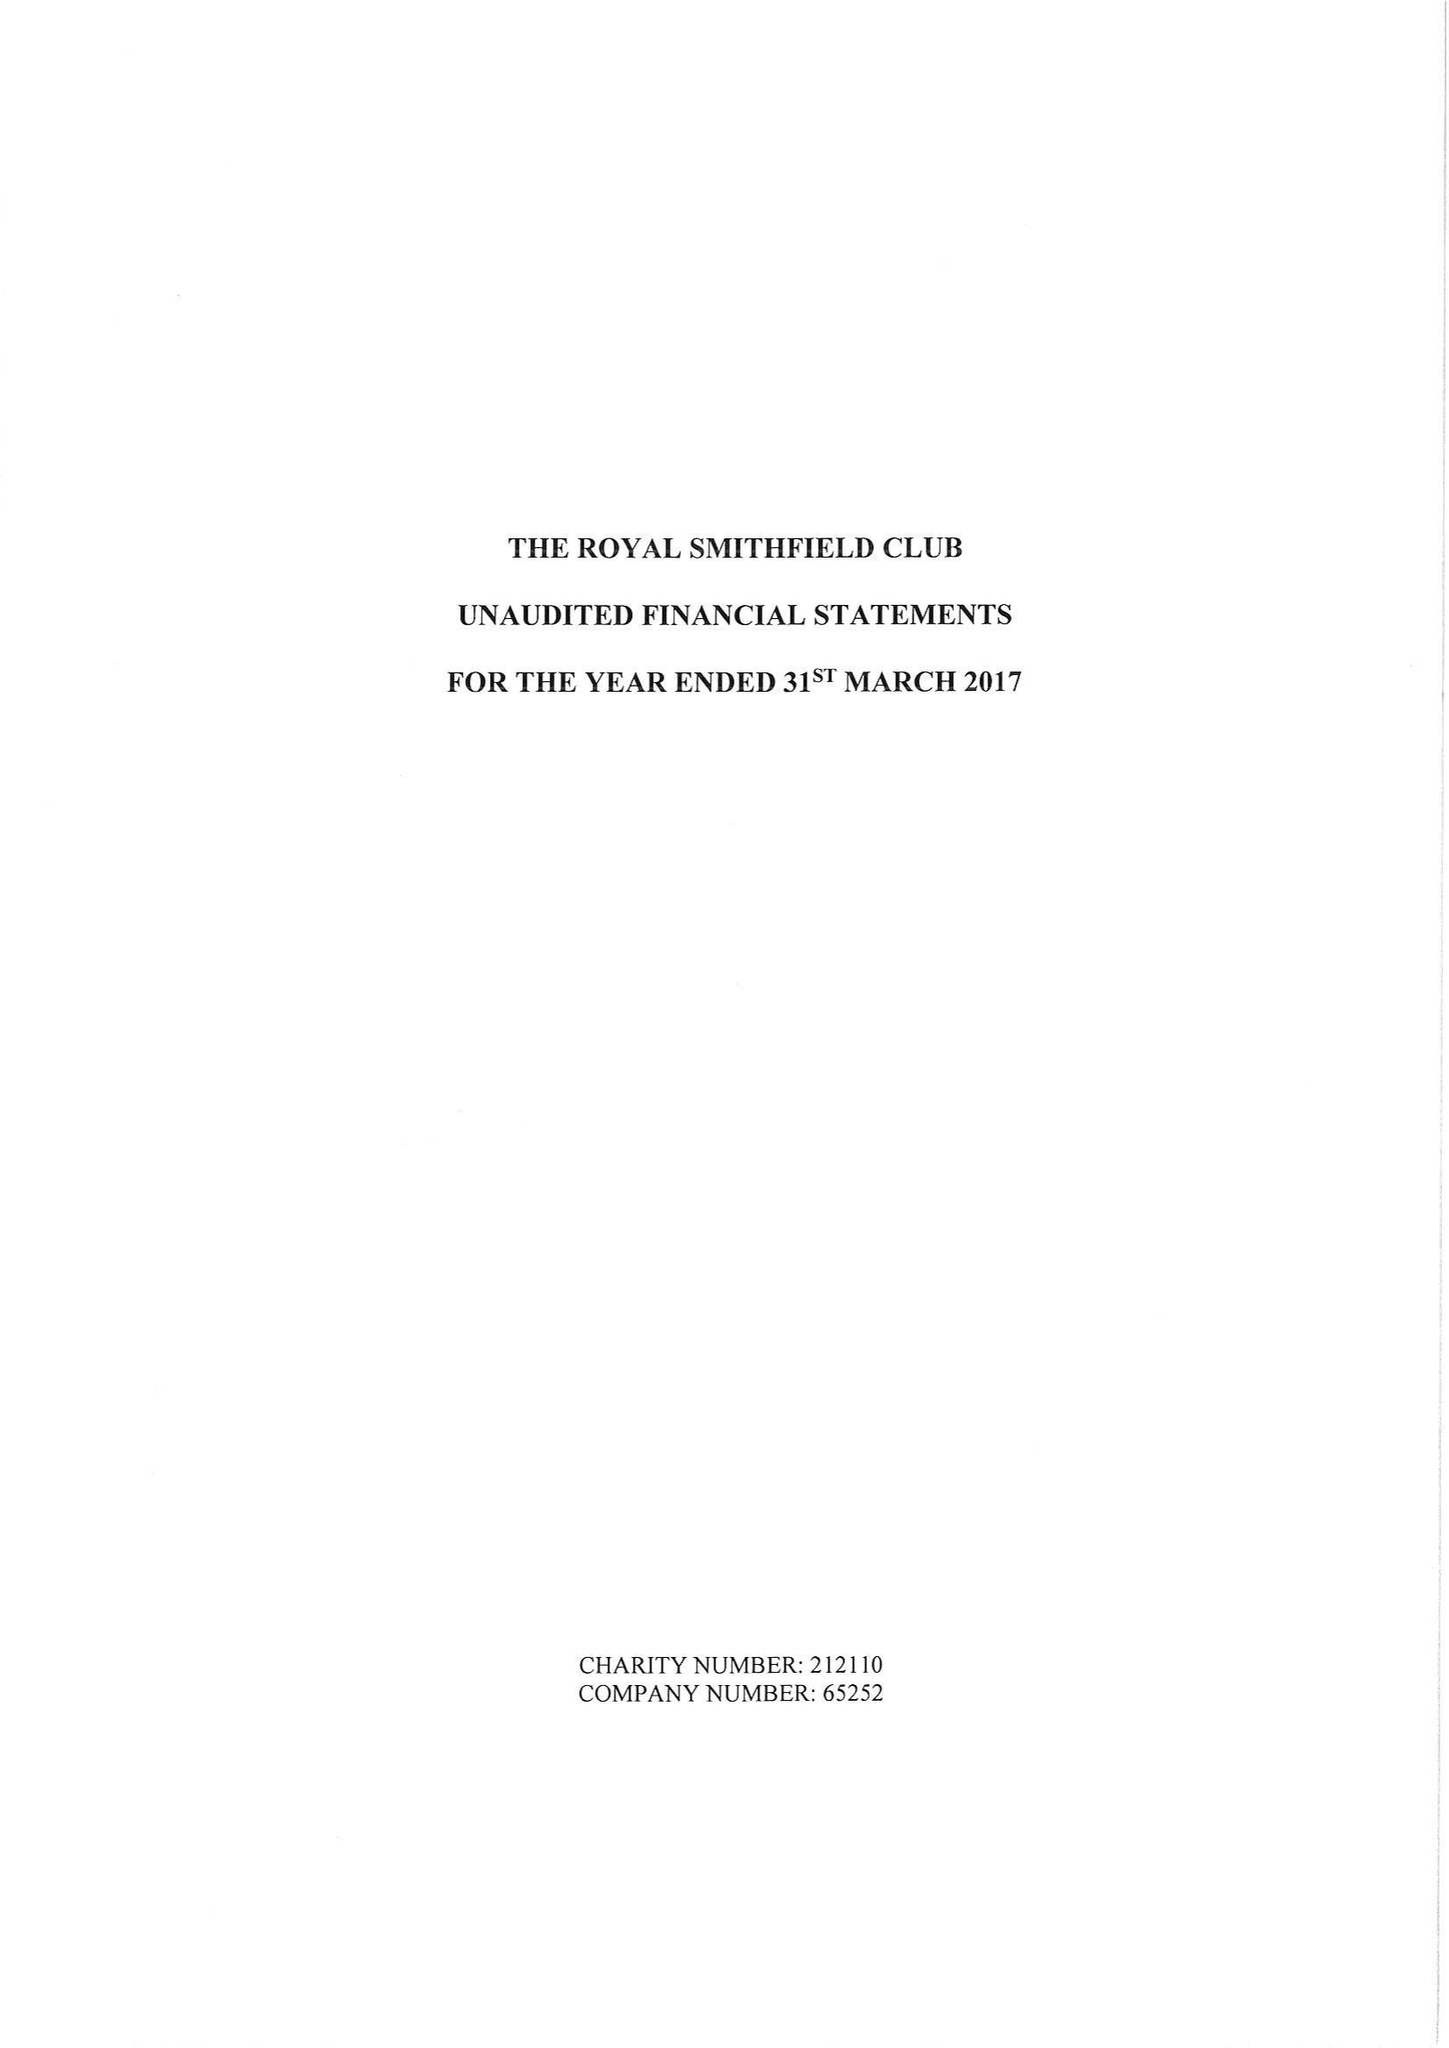What is the value for the income_annually_in_british_pounds?
Answer the question using a single word or phrase. 25293.00 